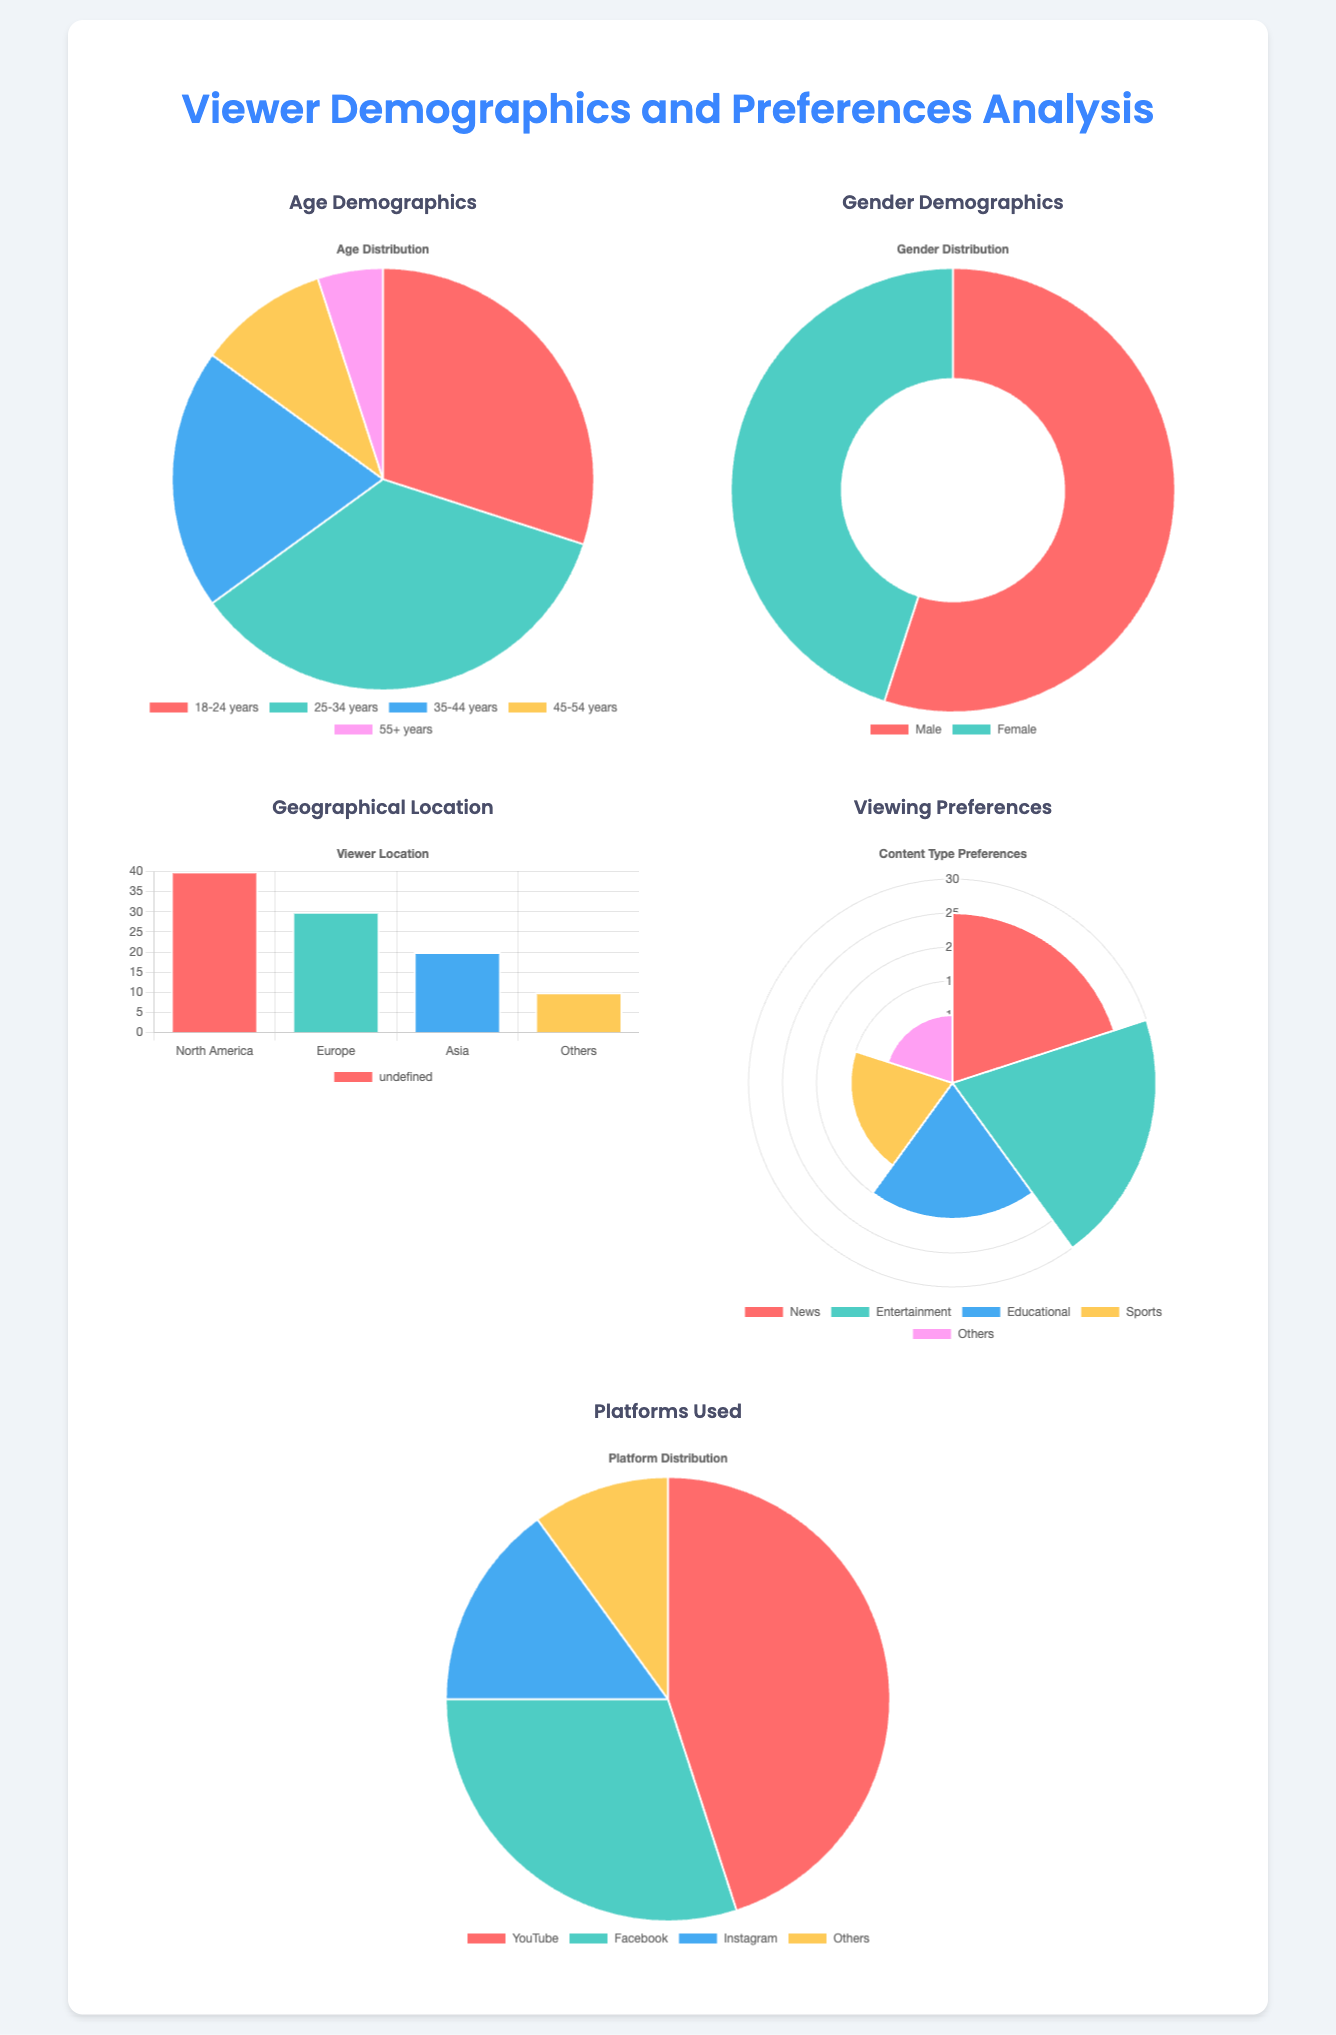what is the largest age demographic group? The largest age demographic group is the one with the highest percentage in the chart, which is 25-34 years.
Answer: 25-34 years what percentage of viewers are female? This percentage can be found in the gender demographics chart, showing the portion of female viewers.
Answer: 45 which geographical location has the most viewers? The chart shows the geographical distribution of viewers, revealing the area with the highest percentage.
Answer: North America what is the total percentage of viewers preferring educational content? The preferences chart indicates the percentage of viewers who prefer educational content.
Answer: 20 how many platforms are used in total? The platforms chart lists several platforms used by viewers, providing a count of them.
Answer: 4 which content type has the least preference? By analyzing the content type preferences chart, the type with the least preference can be identified.
Answer: Others if the total viewers were 1000, how many would prefer news? This is calculated from the percentage found in the preferences chart, with news preference being converted into a numeric value.
Answer: 250 what is the ratio of male to female viewers? The gender demographics chart provides the numbers of male and female viewers, which can be used to find the ratio.
Answer: 11:9 